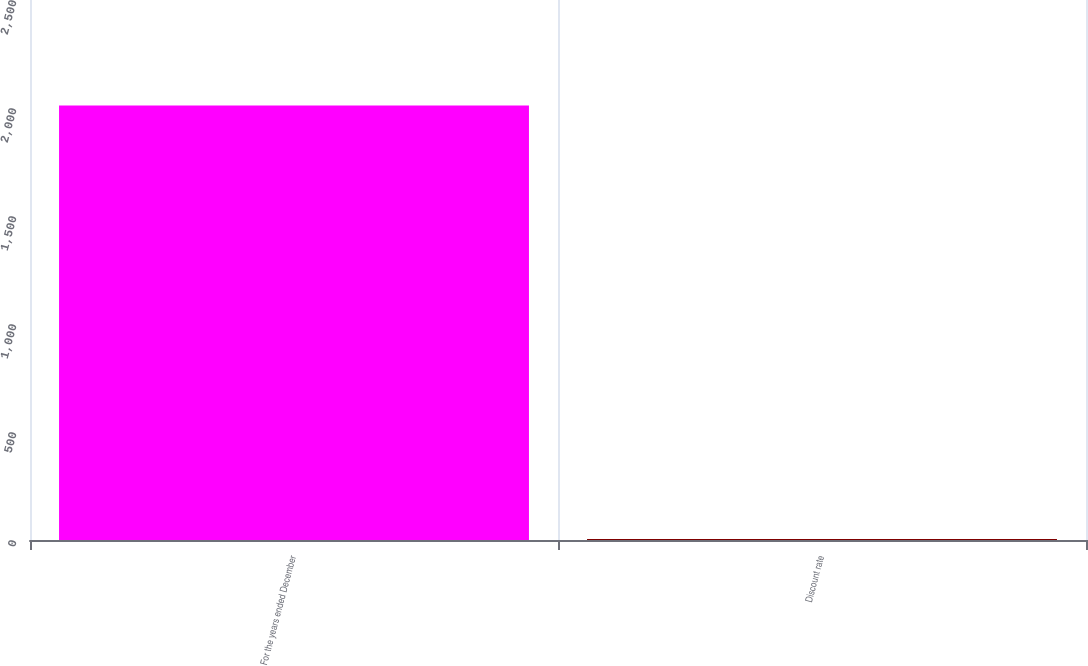Convert chart. <chart><loc_0><loc_0><loc_500><loc_500><bar_chart><fcel>For the years ended December<fcel>Discount rate<nl><fcel>2012<fcel>4.5<nl></chart> 